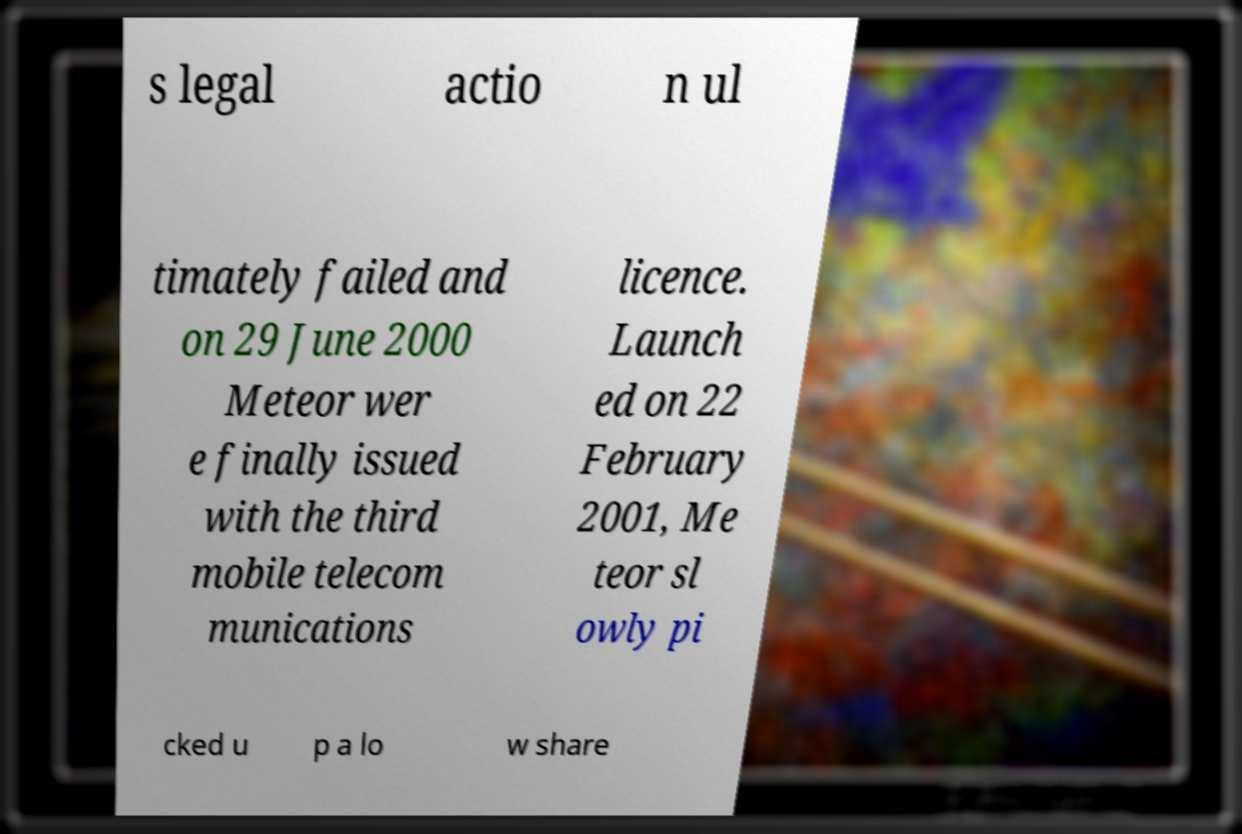Could you assist in decoding the text presented in this image and type it out clearly? s legal actio n ul timately failed and on 29 June 2000 Meteor wer e finally issued with the third mobile telecom munications licence. Launch ed on 22 February 2001, Me teor sl owly pi cked u p a lo w share 